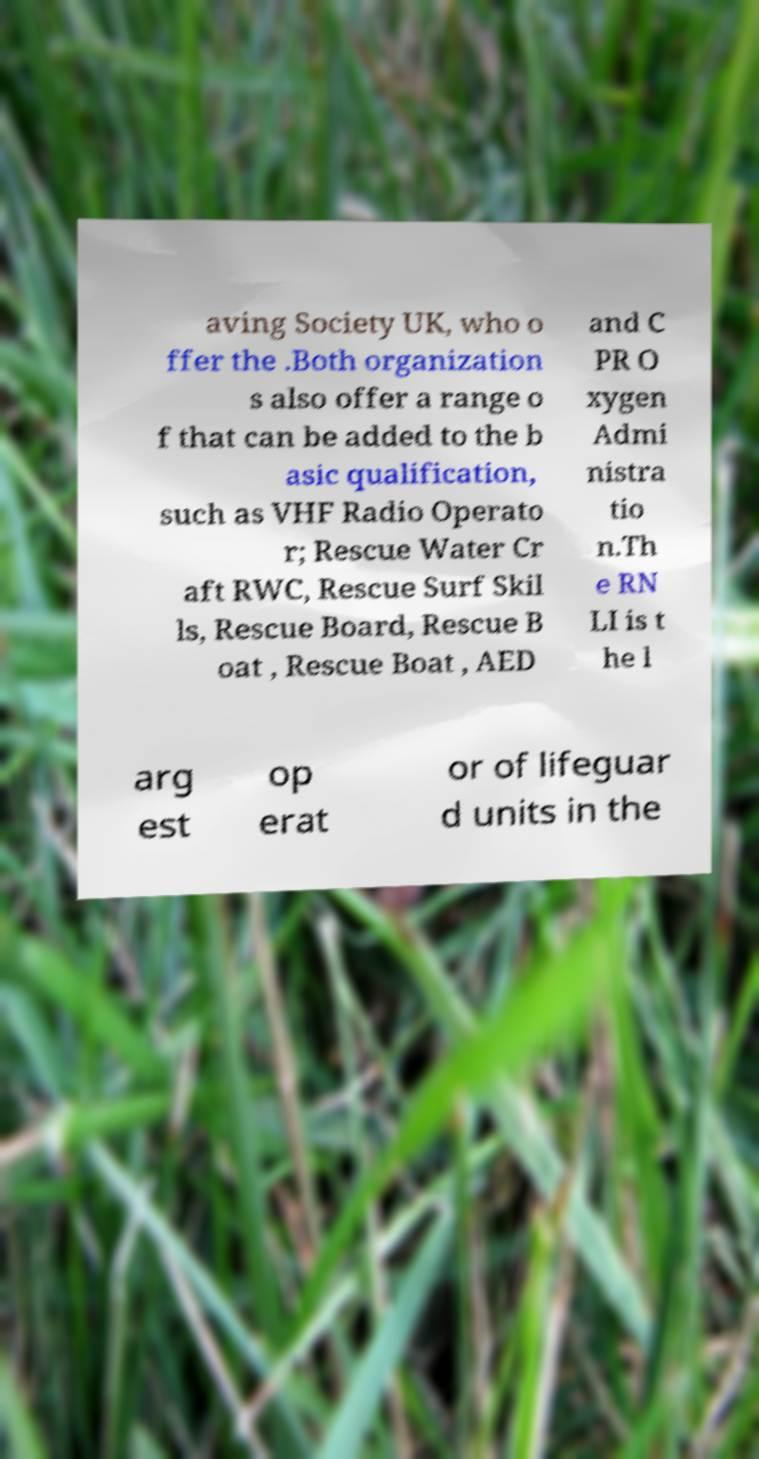For documentation purposes, I need the text within this image transcribed. Could you provide that? aving Society UK, who o ffer the .Both organization s also offer a range o f that can be added to the b asic qualification, such as VHF Radio Operato r; Rescue Water Cr aft RWC, Rescue Surf Skil ls, Rescue Board, Rescue B oat , Rescue Boat , AED and C PR O xygen Admi nistra tio n.Th e RN LI is t he l arg est op erat or of lifeguar d units in the 